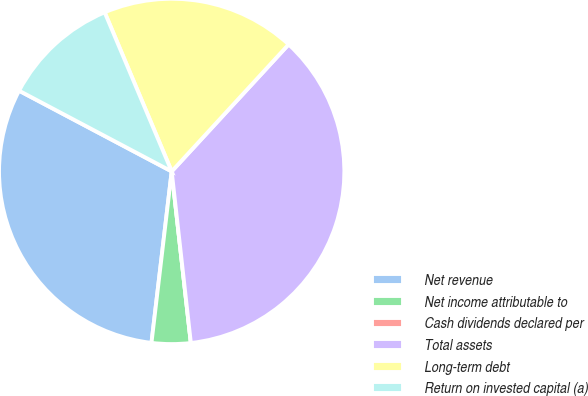Convert chart to OTSL. <chart><loc_0><loc_0><loc_500><loc_500><pie_chart><fcel>Net revenue<fcel>Net income attributable to<fcel>Cash dividends declared per<fcel>Total assets<fcel>Long-term debt<fcel>Return on invested capital (a)<nl><fcel>30.87%<fcel>3.64%<fcel>0.0%<fcel>36.38%<fcel>18.19%<fcel>10.91%<nl></chart> 